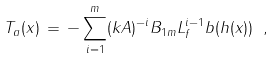Convert formula to latex. <formula><loc_0><loc_0><loc_500><loc_500>T _ { a } ( x ) \, = \, - \sum _ { i = 1 } ^ { m } ( k A ) ^ { - i } B _ { 1 m } L _ { f } ^ { i - 1 } b ( h ( x ) ) \ ,</formula> 